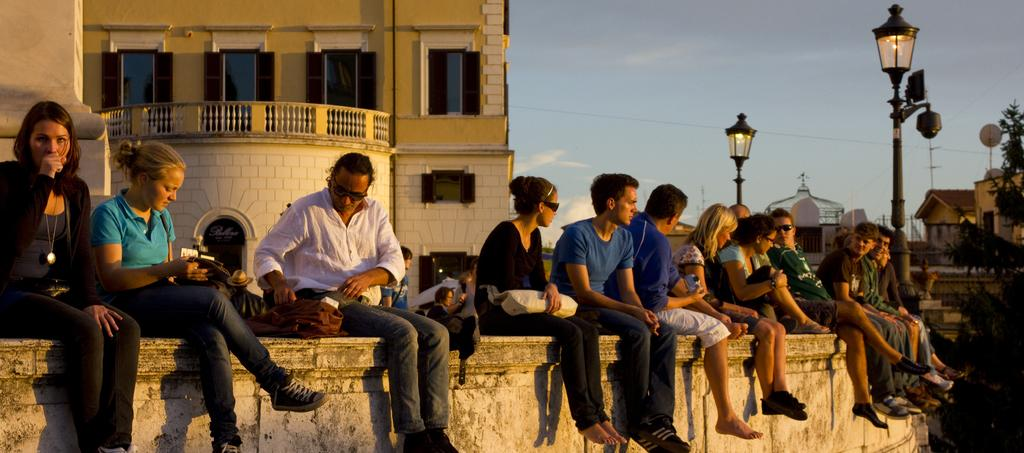What are the people in the image doing? The people in the image are sitting on the wall. What structures can be seen in the image? Street poles, street lights, trees, and buildings are visible in the image. What is visible in the background of the image? The sky is visible in the image, and clouds are present in the sky. What type of belief can be seen in the image? There is no belief present in the image; it features people sitting on a wall, street poles, street lights, trees, buildings, and the sky. How many babies are visible in the image? There are no babies present in the image. 